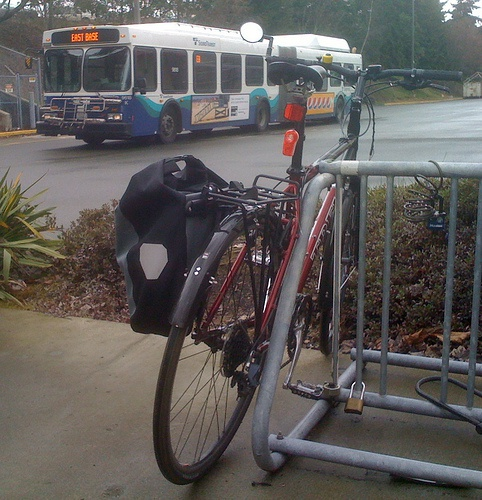Describe the objects in this image and their specific colors. I can see bicycle in white, black, gray, darkgray, and maroon tones and bus in white, gray, lightgray, darkgray, and darkblue tones in this image. 